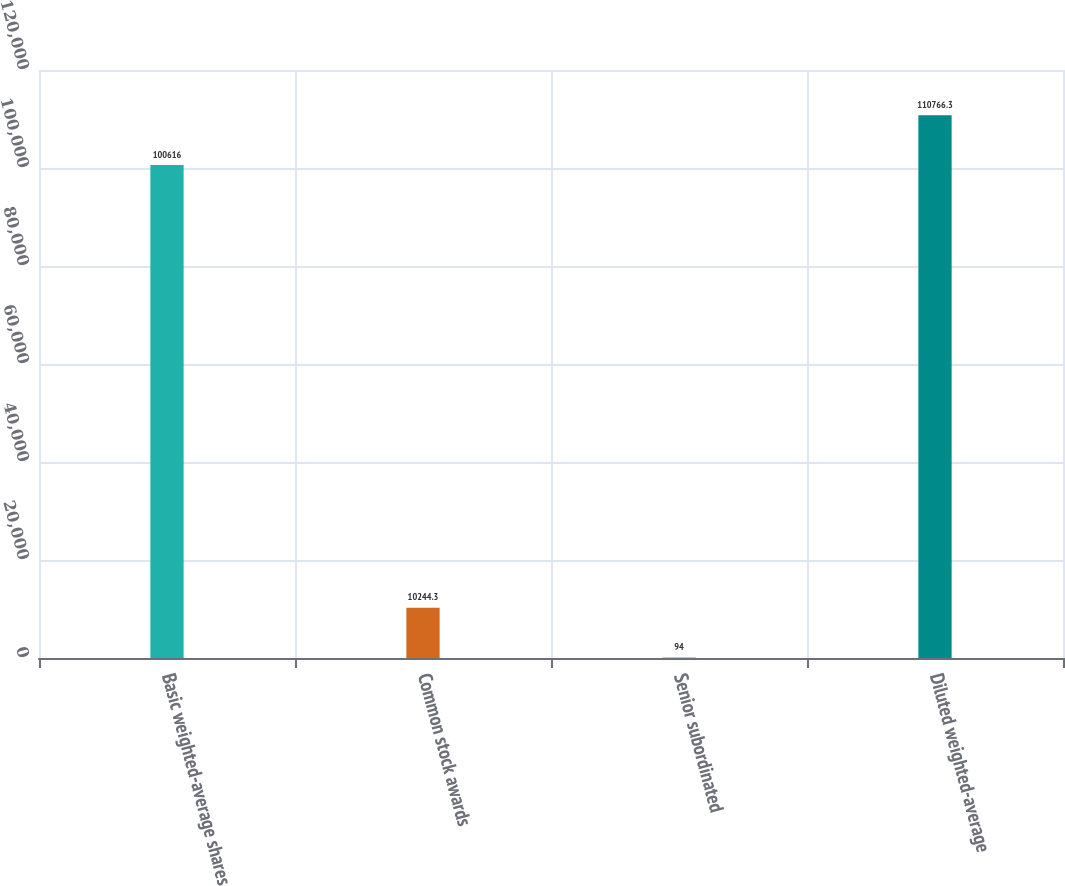<chart> <loc_0><loc_0><loc_500><loc_500><bar_chart><fcel>Basic weighted-average shares<fcel>Common stock awards<fcel>Senior subordinated<fcel>Diluted weighted-average<nl><fcel>100616<fcel>10244.3<fcel>94<fcel>110766<nl></chart> 